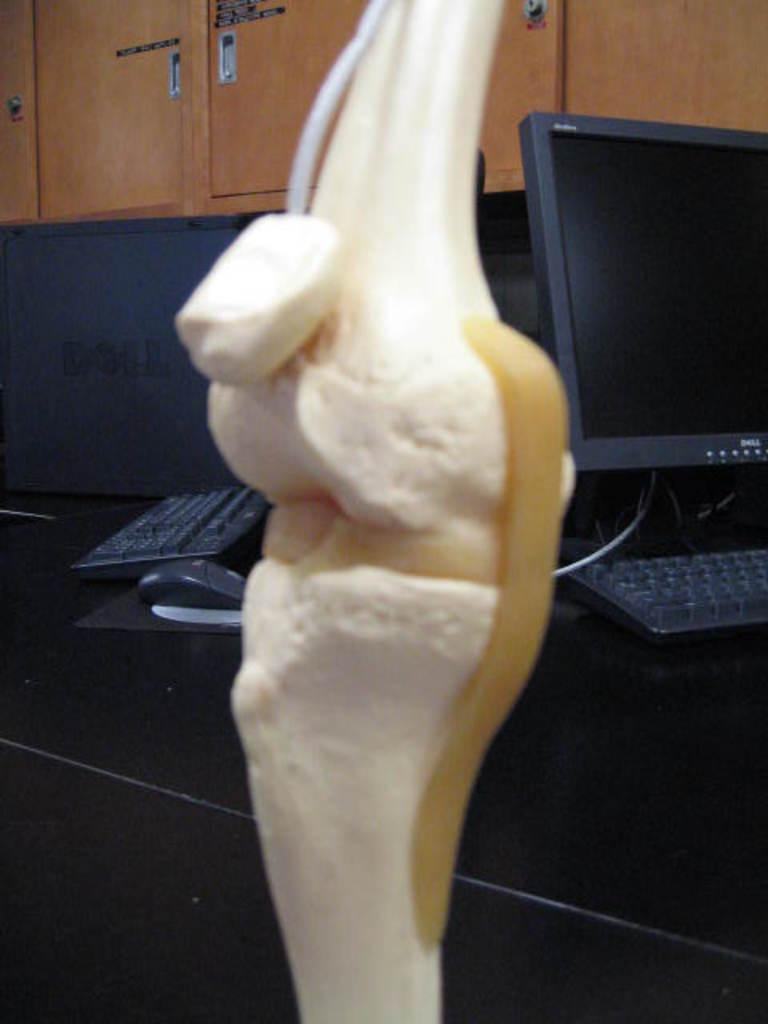What is the main object in the center of the image? There is an object in the center of the image, but its specific nature is not mentioned in the facts. What type of equipment can be seen in the background of the image? In the background of the image, there are computers, keyboards, and a mouse (computer peripheral). What type of furniture is present in the background of the image? There are cupboards in the background of the image. What type of committee is meeting in the image? There is no committee present in the image; it features an object in the center and various equipment and furniture in the background. Can you see any mountains in the image? There are no mountains present in the image. 